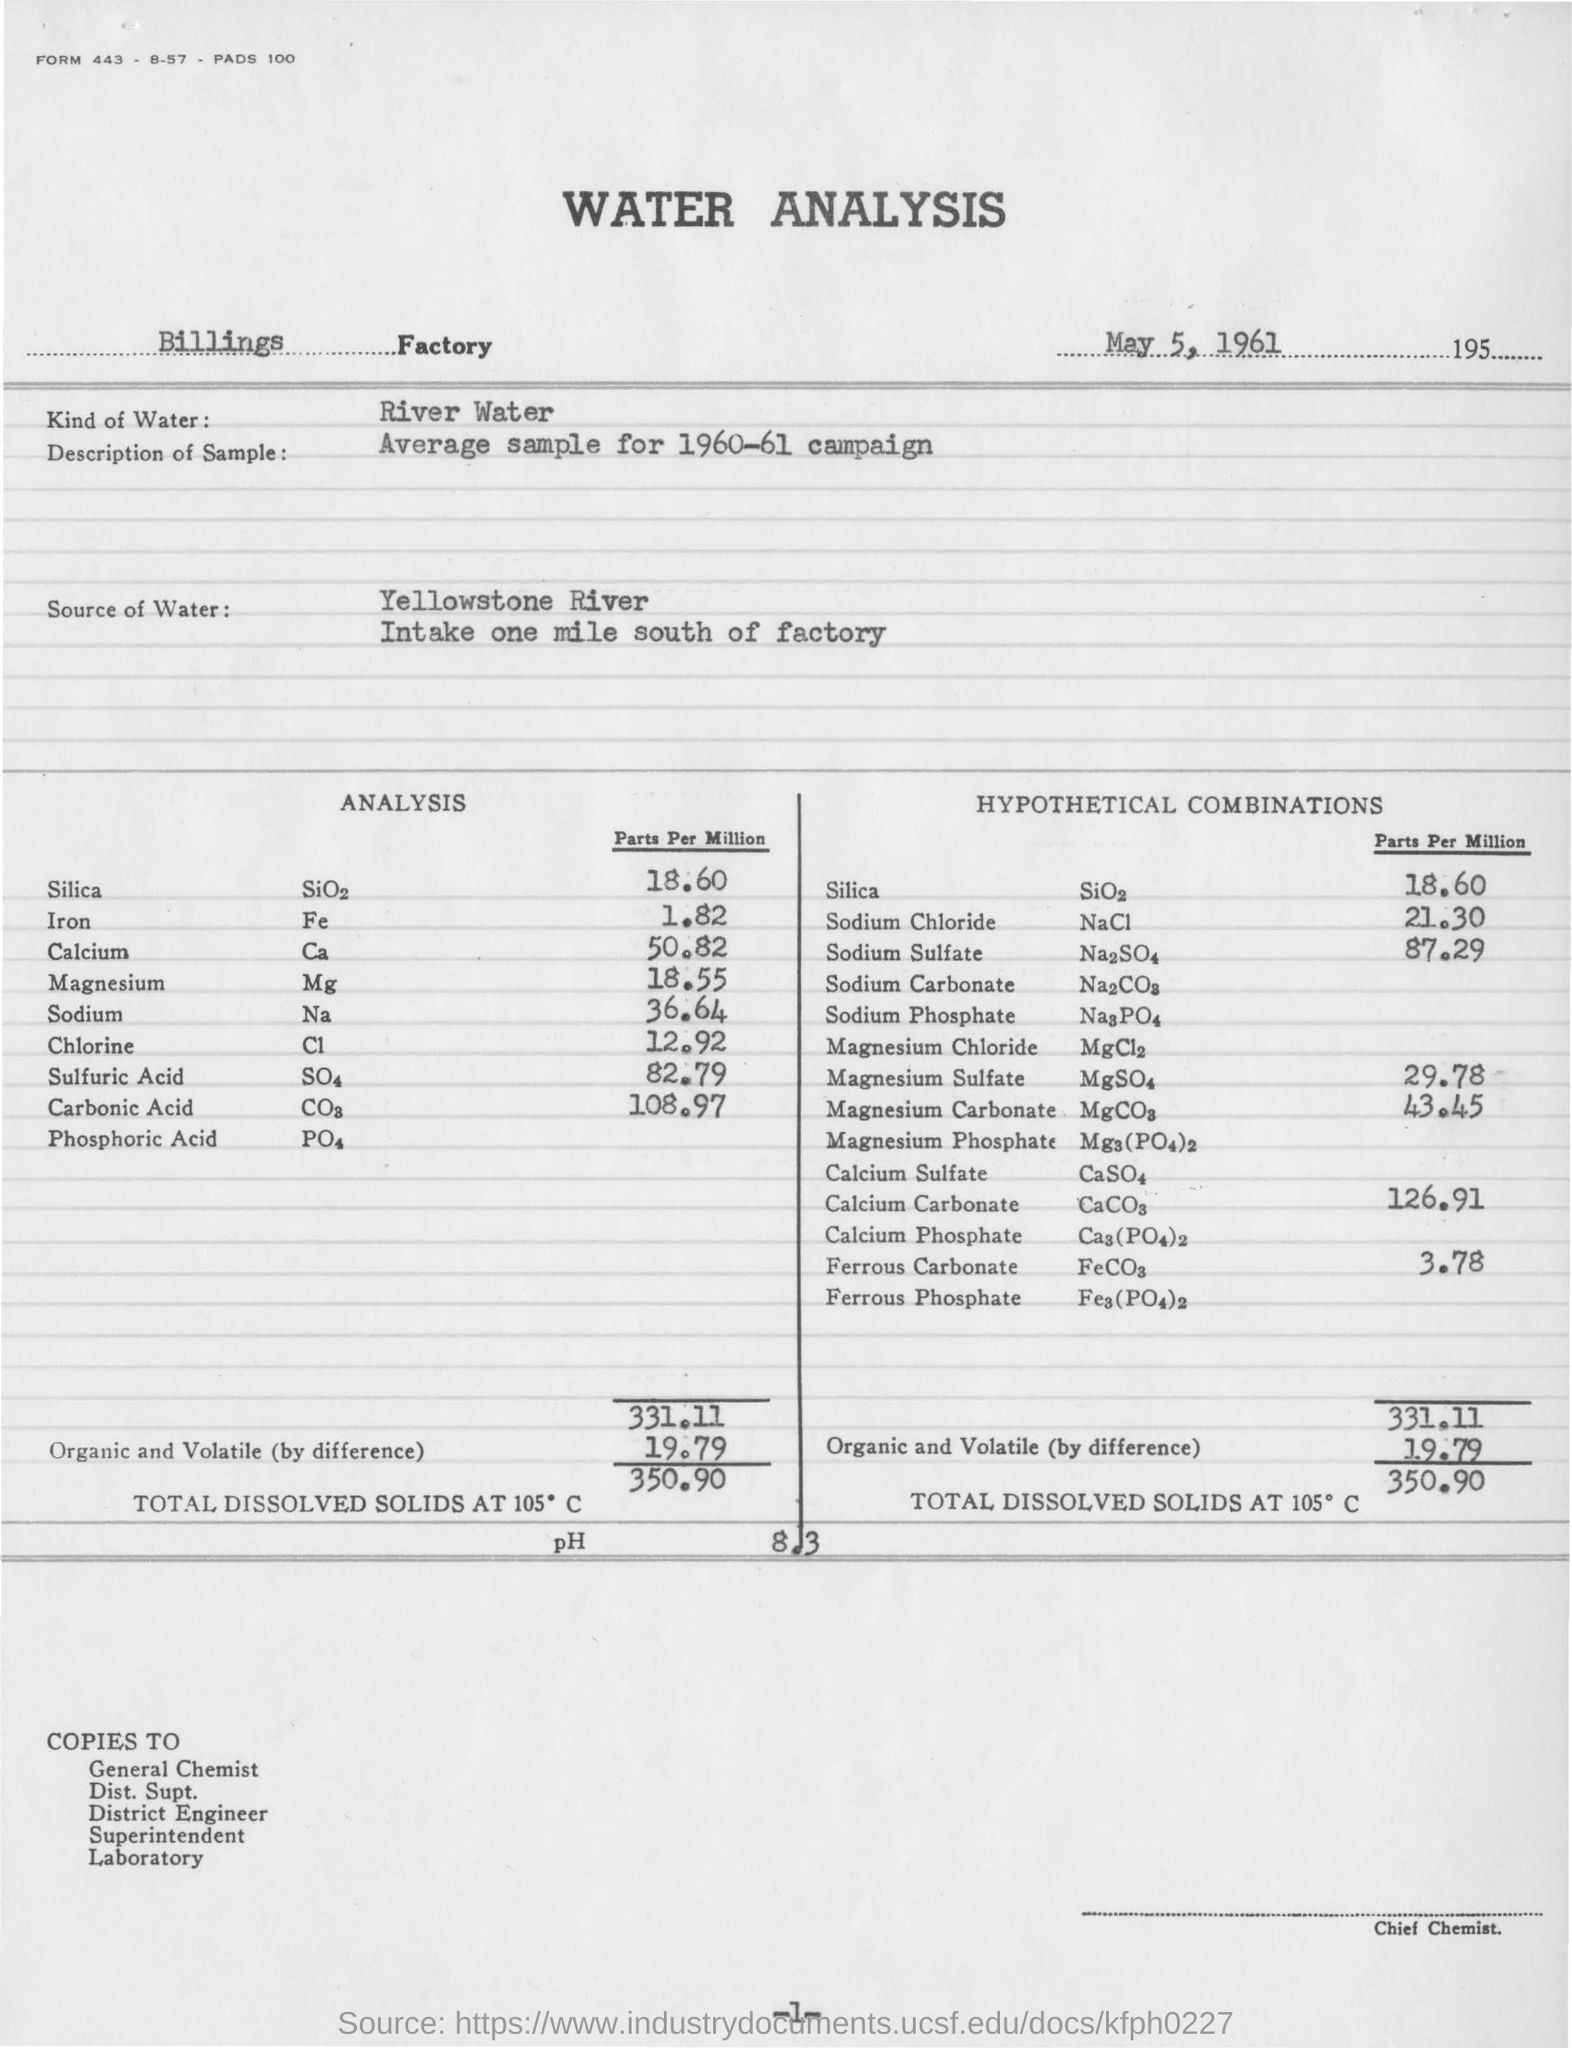Outline some significant characteristics in this image. According to the analysis, the silica content is 18.60 parts per million. I have determined that the water in question is river water. The total dissolved solids at 105 degrees Celsius is 350.90. The heading of the document is "Water Analysis... Yellowstone River is the source of the water. 